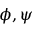Convert formula to latex. <formula><loc_0><loc_0><loc_500><loc_500>\phi , \psi</formula> 